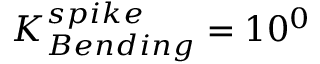<formula> <loc_0><loc_0><loc_500><loc_500>K _ { B e n d i n g } ^ { s p i k e } = 1 0 ^ { 0 }</formula> 